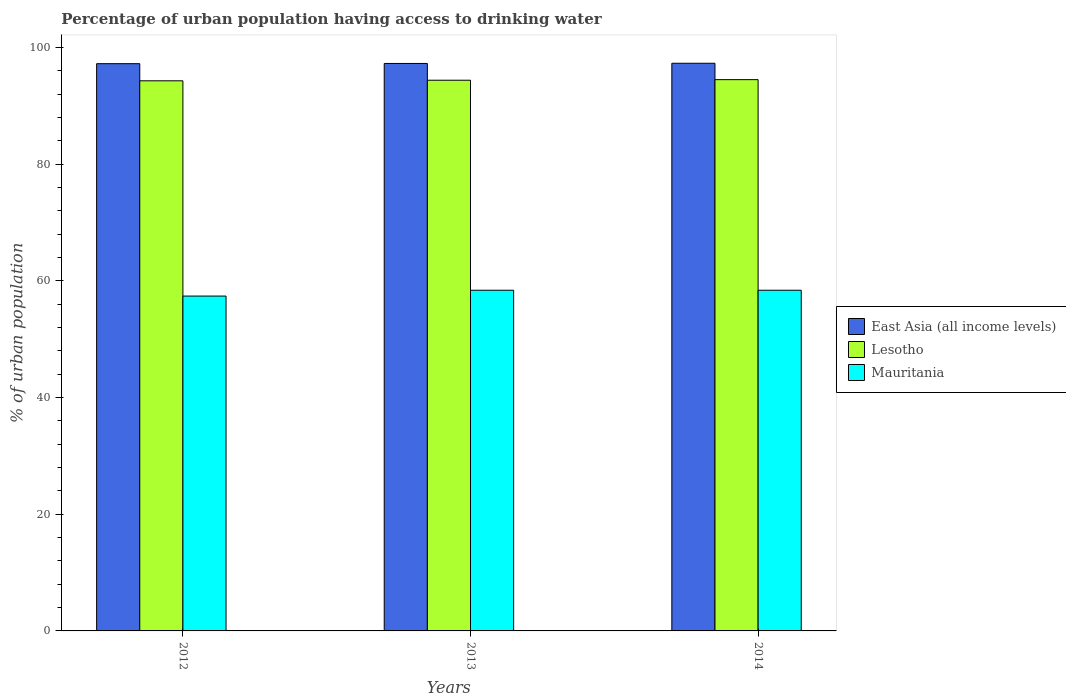How many different coloured bars are there?
Make the answer very short. 3. How many groups of bars are there?
Your answer should be compact. 3. Are the number of bars per tick equal to the number of legend labels?
Provide a succinct answer. Yes. In how many cases, is the number of bars for a given year not equal to the number of legend labels?
Your response must be concise. 0. What is the percentage of urban population having access to drinking water in Lesotho in 2014?
Offer a very short reply. 94.5. Across all years, what is the maximum percentage of urban population having access to drinking water in Mauritania?
Your answer should be compact. 58.4. Across all years, what is the minimum percentage of urban population having access to drinking water in Lesotho?
Provide a short and direct response. 94.3. In which year was the percentage of urban population having access to drinking water in Mauritania minimum?
Your answer should be compact. 2012. What is the total percentage of urban population having access to drinking water in Mauritania in the graph?
Offer a very short reply. 174.2. What is the difference between the percentage of urban population having access to drinking water in East Asia (all income levels) in 2012 and that in 2013?
Keep it short and to the point. -0.04. What is the difference between the percentage of urban population having access to drinking water in Lesotho in 2014 and the percentage of urban population having access to drinking water in Mauritania in 2013?
Offer a very short reply. 36.1. What is the average percentage of urban population having access to drinking water in Mauritania per year?
Offer a terse response. 58.07. In the year 2012, what is the difference between the percentage of urban population having access to drinking water in Lesotho and percentage of urban population having access to drinking water in Mauritania?
Keep it short and to the point. 36.9. What is the ratio of the percentage of urban population having access to drinking water in Mauritania in 2012 to that in 2014?
Make the answer very short. 0.98. Is the difference between the percentage of urban population having access to drinking water in Lesotho in 2012 and 2014 greater than the difference between the percentage of urban population having access to drinking water in Mauritania in 2012 and 2014?
Your response must be concise. Yes. What is the difference between the highest and the second highest percentage of urban population having access to drinking water in East Asia (all income levels)?
Make the answer very short. 0.03. What is the difference between the highest and the lowest percentage of urban population having access to drinking water in East Asia (all income levels)?
Offer a terse response. 0.07. What does the 2nd bar from the left in 2013 represents?
Provide a short and direct response. Lesotho. What does the 3rd bar from the right in 2012 represents?
Make the answer very short. East Asia (all income levels). How many bars are there?
Your answer should be very brief. 9. Are all the bars in the graph horizontal?
Offer a terse response. No. How many years are there in the graph?
Give a very brief answer. 3. Does the graph contain any zero values?
Offer a terse response. No. Does the graph contain grids?
Your response must be concise. No. Where does the legend appear in the graph?
Give a very brief answer. Center right. How many legend labels are there?
Offer a terse response. 3. How are the legend labels stacked?
Your answer should be compact. Vertical. What is the title of the graph?
Make the answer very short. Percentage of urban population having access to drinking water. Does "Slovenia" appear as one of the legend labels in the graph?
Provide a short and direct response. No. What is the label or title of the X-axis?
Keep it short and to the point. Years. What is the label or title of the Y-axis?
Your response must be concise. % of urban population. What is the % of urban population of East Asia (all income levels) in 2012?
Provide a short and direct response. 97.24. What is the % of urban population in Lesotho in 2012?
Give a very brief answer. 94.3. What is the % of urban population of Mauritania in 2012?
Ensure brevity in your answer.  57.4. What is the % of urban population in East Asia (all income levels) in 2013?
Offer a very short reply. 97.27. What is the % of urban population in Lesotho in 2013?
Provide a short and direct response. 94.4. What is the % of urban population in Mauritania in 2013?
Offer a terse response. 58.4. What is the % of urban population of East Asia (all income levels) in 2014?
Keep it short and to the point. 97.31. What is the % of urban population in Lesotho in 2014?
Your answer should be very brief. 94.5. What is the % of urban population of Mauritania in 2014?
Offer a terse response. 58.4. Across all years, what is the maximum % of urban population in East Asia (all income levels)?
Make the answer very short. 97.31. Across all years, what is the maximum % of urban population in Lesotho?
Your answer should be compact. 94.5. Across all years, what is the maximum % of urban population of Mauritania?
Make the answer very short. 58.4. Across all years, what is the minimum % of urban population in East Asia (all income levels)?
Give a very brief answer. 97.24. Across all years, what is the minimum % of urban population in Lesotho?
Ensure brevity in your answer.  94.3. Across all years, what is the minimum % of urban population of Mauritania?
Provide a short and direct response. 57.4. What is the total % of urban population of East Asia (all income levels) in the graph?
Offer a very short reply. 291.82. What is the total % of urban population of Lesotho in the graph?
Offer a terse response. 283.2. What is the total % of urban population in Mauritania in the graph?
Your answer should be very brief. 174.2. What is the difference between the % of urban population in East Asia (all income levels) in 2012 and that in 2013?
Offer a very short reply. -0.04. What is the difference between the % of urban population of East Asia (all income levels) in 2012 and that in 2014?
Your answer should be compact. -0.07. What is the difference between the % of urban population of Lesotho in 2012 and that in 2014?
Ensure brevity in your answer.  -0.2. What is the difference between the % of urban population of Mauritania in 2012 and that in 2014?
Offer a terse response. -1. What is the difference between the % of urban population of East Asia (all income levels) in 2013 and that in 2014?
Give a very brief answer. -0.03. What is the difference between the % of urban population in Lesotho in 2013 and that in 2014?
Your answer should be compact. -0.1. What is the difference between the % of urban population of East Asia (all income levels) in 2012 and the % of urban population of Lesotho in 2013?
Provide a short and direct response. 2.84. What is the difference between the % of urban population in East Asia (all income levels) in 2012 and the % of urban population in Mauritania in 2013?
Make the answer very short. 38.84. What is the difference between the % of urban population in Lesotho in 2012 and the % of urban population in Mauritania in 2013?
Offer a terse response. 35.9. What is the difference between the % of urban population of East Asia (all income levels) in 2012 and the % of urban population of Lesotho in 2014?
Your answer should be very brief. 2.74. What is the difference between the % of urban population in East Asia (all income levels) in 2012 and the % of urban population in Mauritania in 2014?
Your answer should be compact. 38.84. What is the difference between the % of urban population of Lesotho in 2012 and the % of urban population of Mauritania in 2014?
Your answer should be very brief. 35.9. What is the difference between the % of urban population in East Asia (all income levels) in 2013 and the % of urban population in Lesotho in 2014?
Give a very brief answer. 2.77. What is the difference between the % of urban population in East Asia (all income levels) in 2013 and the % of urban population in Mauritania in 2014?
Ensure brevity in your answer.  38.87. What is the difference between the % of urban population of Lesotho in 2013 and the % of urban population of Mauritania in 2014?
Give a very brief answer. 36. What is the average % of urban population in East Asia (all income levels) per year?
Your answer should be compact. 97.27. What is the average % of urban population in Lesotho per year?
Your response must be concise. 94.4. What is the average % of urban population in Mauritania per year?
Keep it short and to the point. 58.07. In the year 2012, what is the difference between the % of urban population in East Asia (all income levels) and % of urban population in Lesotho?
Provide a short and direct response. 2.94. In the year 2012, what is the difference between the % of urban population of East Asia (all income levels) and % of urban population of Mauritania?
Make the answer very short. 39.84. In the year 2012, what is the difference between the % of urban population of Lesotho and % of urban population of Mauritania?
Keep it short and to the point. 36.9. In the year 2013, what is the difference between the % of urban population in East Asia (all income levels) and % of urban population in Lesotho?
Provide a short and direct response. 2.87. In the year 2013, what is the difference between the % of urban population of East Asia (all income levels) and % of urban population of Mauritania?
Ensure brevity in your answer.  38.87. In the year 2013, what is the difference between the % of urban population of Lesotho and % of urban population of Mauritania?
Ensure brevity in your answer.  36. In the year 2014, what is the difference between the % of urban population of East Asia (all income levels) and % of urban population of Lesotho?
Give a very brief answer. 2.81. In the year 2014, what is the difference between the % of urban population in East Asia (all income levels) and % of urban population in Mauritania?
Your answer should be very brief. 38.91. In the year 2014, what is the difference between the % of urban population of Lesotho and % of urban population of Mauritania?
Offer a terse response. 36.1. What is the ratio of the % of urban population in Mauritania in 2012 to that in 2013?
Keep it short and to the point. 0.98. What is the ratio of the % of urban population of Mauritania in 2012 to that in 2014?
Provide a succinct answer. 0.98. What is the ratio of the % of urban population in East Asia (all income levels) in 2013 to that in 2014?
Your response must be concise. 1. What is the ratio of the % of urban population of Mauritania in 2013 to that in 2014?
Give a very brief answer. 1. What is the difference between the highest and the second highest % of urban population in East Asia (all income levels)?
Ensure brevity in your answer.  0.03. What is the difference between the highest and the second highest % of urban population in Mauritania?
Your answer should be very brief. 0. What is the difference between the highest and the lowest % of urban population of East Asia (all income levels)?
Offer a very short reply. 0.07. What is the difference between the highest and the lowest % of urban population of Mauritania?
Provide a succinct answer. 1. 